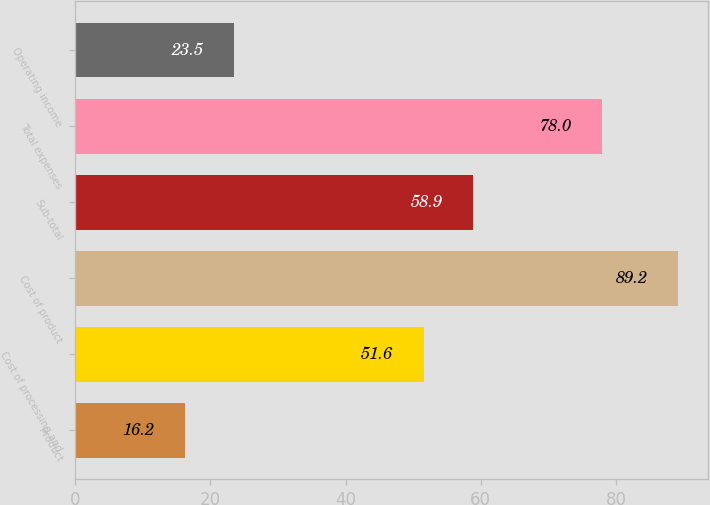Convert chart to OTSL. <chart><loc_0><loc_0><loc_500><loc_500><bar_chart><fcel>Product<fcel>Cost of processing and<fcel>Cost of product<fcel>Sub-total<fcel>Total expenses<fcel>Operating income<nl><fcel>16.2<fcel>51.6<fcel>89.2<fcel>58.9<fcel>78<fcel>23.5<nl></chart> 